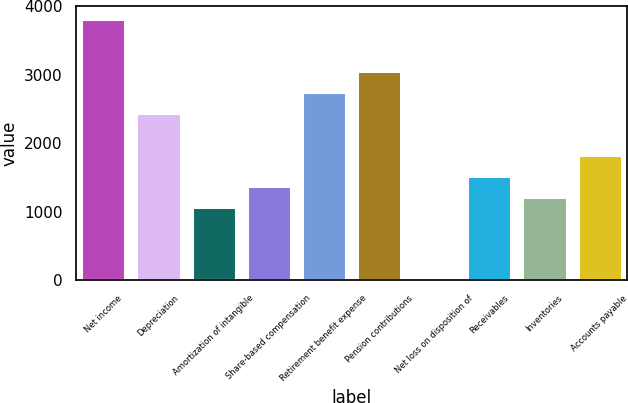Convert chart to OTSL. <chart><loc_0><loc_0><loc_500><loc_500><bar_chart><fcel>Net income<fcel>Depreciation<fcel>Amortization of intangible<fcel>Share-based compensation<fcel>Retirement benefit expense<fcel>Pension contributions<fcel>Net loss on disposition of<fcel>Receivables<fcel>Inventories<fcel>Accounts payable<nl><fcel>3815.85<fcel>2442.18<fcel>1068.51<fcel>1373.77<fcel>2747.44<fcel>3052.7<fcel>0.1<fcel>1526.4<fcel>1221.14<fcel>1831.66<nl></chart> 